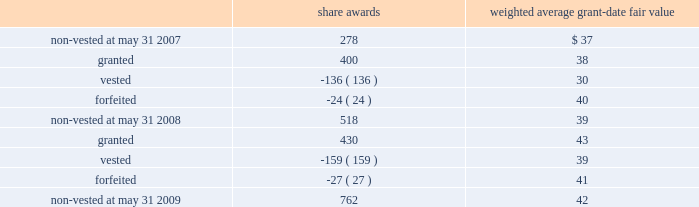Notes to consolidated financial statements 2014 ( continued ) the table summarizes the changes in non-vested restricted stock awards for the year ended may 31 , 2009 ( share awards in thousands ) : share awards weighted average grant-date fair value .
The weighted average grant-date fair value of share awards granted in the years ended may 31 , 2008 and 2007 was $ 38 and $ 45 , respectively .
The total fair value of share awards vested during the years ended may 31 , 2009 , 2008 and 2007 was $ 6.2 million , $ 4.1 million and $ 1.7 million , respectively .
We recognized compensation expense for restricted stock of $ 9.0 million , $ 5.7 million , and $ 2.7 million in the years ended may 31 , 2009 , 2008 and 2007 .
As of may 31 , 2009 , there was $ 23.5 million of total unrecognized compensation cost related to unvested restricted stock awards that is expected to be recognized over a weighted average period of 2.9 years .
Employee stock purchase plan we have an employee stock purchase plan under which the sale of 2.4 million shares of our common stock has been authorized .
Employees may designate up to the lesser of $ 25000 or 20% ( 20 % ) of their annual compensation for the purchase of stock .
The price for shares purchased under the plan is 85% ( 85 % ) of the market value on the last day of the quarterly purchase period .
As of may 31 , 2009 , 0.8 million shares had been issued under this plan , with 1.6 million shares reserved for future issuance .
The weighted average grant-date fair value of each designated share purchased under this plan was $ 6 , $ 6 and $ 8 in the years ended may 31 , 2009 , 2008 and 2007 , respectively .
These values represent the fair value of the 15% ( 15 % ) discount .
Note 12 2014segment information general information during fiscal 2009 , we began assessing our operating performance using a new segment structure .
We made this change as a result of our june 30 , 2008 acquisition of 51% ( 51 % ) of hsbc merchant services llp in the united kingdom , in addition to anticipated future international expansion .
Beginning with the quarter ended august 31 , 2008 , the reportable segments are defined as north america merchant services , international merchant services , and money transfer .
The following tables reflect these changes and such reportable segments for fiscal years 2009 , 2008 , and 2007. .
What was the percentage increase of total fair value of share awards vested from 2007 to 2009? 
Rationale: to find the percentage increase one must subtract the total fair value of share awards vested of 2009 by 2007's total fair value of share awards vested . then you will take this solution and divide it by 2007's total fair value of share awards vested
Computations: ((6.2 - 1.7) / 1.7)
Answer: 2.64706. 